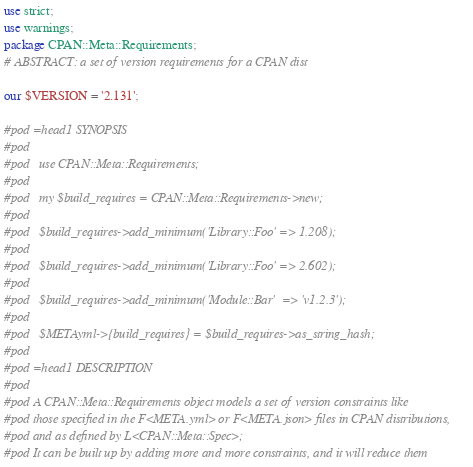<code> <loc_0><loc_0><loc_500><loc_500><_Perl_>use strict;
use warnings;
package CPAN::Meta::Requirements;
# ABSTRACT: a set of version requirements for a CPAN dist

our $VERSION = '2.131';

#pod =head1 SYNOPSIS
#pod
#pod   use CPAN::Meta::Requirements;
#pod
#pod   my $build_requires = CPAN::Meta::Requirements->new;
#pod
#pod   $build_requires->add_minimum('Library::Foo' => 1.208);
#pod
#pod   $build_requires->add_minimum('Library::Foo' => 2.602);
#pod
#pod   $build_requires->add_minimum('Module::Bar'  => 'v1.2.3');
#pod
#pod   $METAyml->{build_requires} = $build_requires->as_string_hash;
#pod
#pod =head1 DESCRIPTION
#pod
#pod A CPAN::Meta::Requirements object models a set of version constraints like
#pod those specified in the F<META.yml> or F<META.json> files in CPAN distributions,
#pod and as defined by L<CPAN::Meta::Spec>;
#pod It can be built up by adding more and more constraints, and it will reduce them</code> 